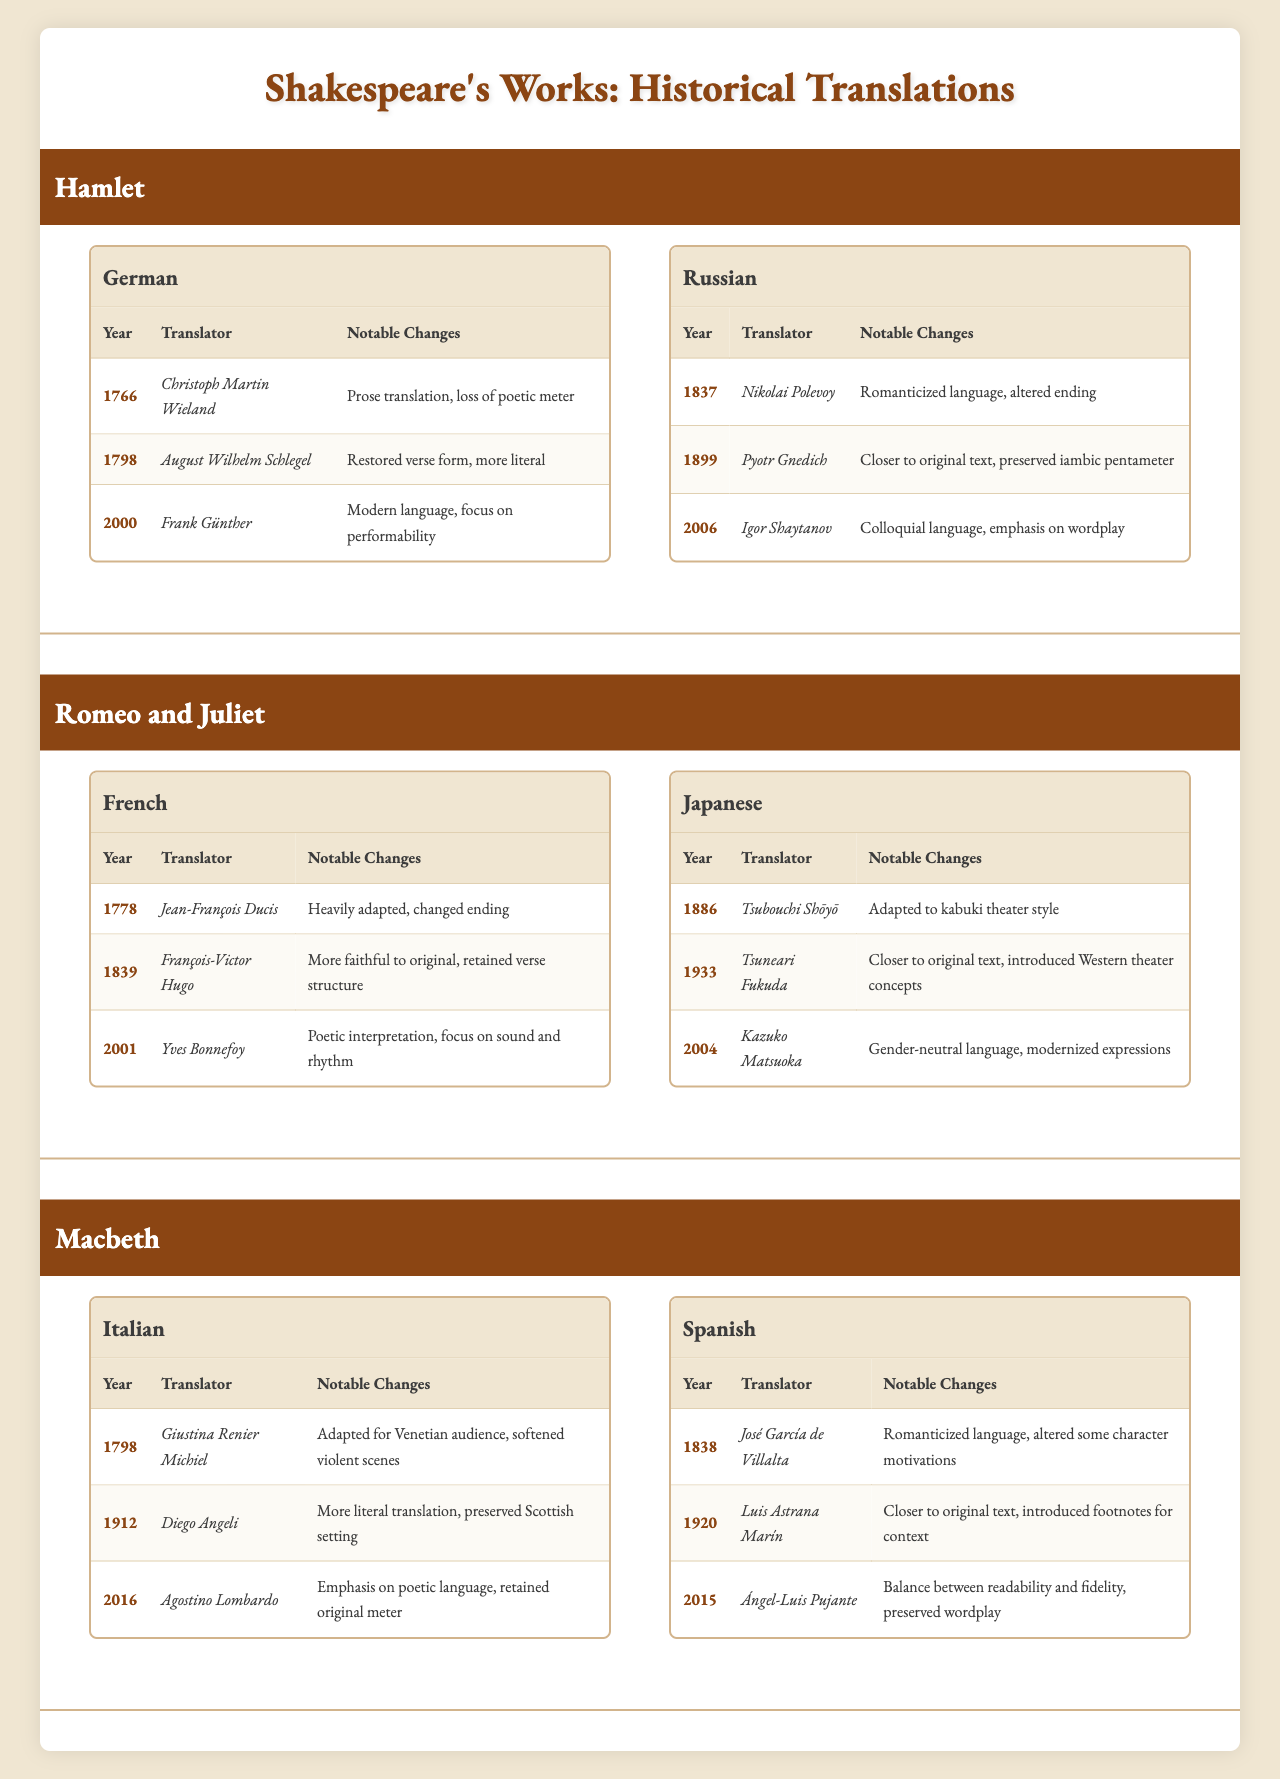What year was the first German translation of Hamlet published? The first German translation of Hamlet was published in 1766 by Christoph Martin Wieland. This information can be found under the German language translations for Hamlet.
Answer: 1766 How many translations of Macbeth are listed in Italian? There are three translations of Macbeth listed in Italian. Each translation corresponds to a different year and translator.
Answer: 3 Which translator is associated with the first Russian translation of Hamlet? The first Russian translation of Hamlet, published in 1837, is associated with Nikolai Polevoy. This can be found in the Russian language translations section for Hamlet.
Answer: Nikolai Polevoy Did any Japanese translations of Romeo and Juliet focus on modernized expressions? Yes, the Japanese translation of Romeo and Juliet by Kazuko Matsuoka in 2004 focused on gender-neutral language and modernized expressions. This is indicated in the notable changes for that translation.
Answer: Yes What are the notable changes in the most recent translation of Macbeth into Spanish? The most recent Spanish translation of Macbeth was done by Ángel-Luis Pujante in 2015, and it aimed to balance readability and fidelity while preserving wordplay. This is detailed under the Spanish translations for Macbeth.
Answer: Balance between readability and fidelity, preserved wordplay What is the average year of translation for Hamlet's works in German? The years of translation for Hamlet in German are 1766, 1798, and 2000. The average year is calculated as (1766 + 1798 + 2000) / 3 = 1788.67, which rounds to 1789 when only considering whole years.
Answer: 1789 Which translator retained the verse structure in the French translation of Romeo and Juliet published in 1839? The French translation of Romeo and Juliet published in 1839 that retained the verse structure was done by François-Victor Hugo, as stated under the translations for that language.
Answer: François-Victor Hugo Was the 1912 Italian translation of Macbeth more literal than the previous one? Yes, the 1912 Italian translation by Diego Angeli is noted for being a more literal translation compared to the previous adaptation done in 1798. This can be verified by comparing the notable changes listed under both translations.
Answer: Yes In how many languages was the play Hamlet translated based on the table? Hamlet was translated into two languages based on the table: German and Russian. Each language has its own set of translations listed.
Answer: 2 Which translation of Romeo and Juliet had a heavily adapted text with a changed ending? The translation of Romeo and Juliet by Jean-François Ducis in 1778 is noted to have a heavily adapted text, which included changing the ending. This detail is found in the French translations under that year.
Answer: Jean-François Ducis 